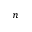<formula> <loc_0><loc_0><loc_500><loc_500>n</formula> 